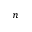<formula> <loc_0><loc_0><loc_500><loc_500>n</formula> 